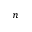<formula> <loc_0><loc_0><loc_500><loc_500>n</formula> 